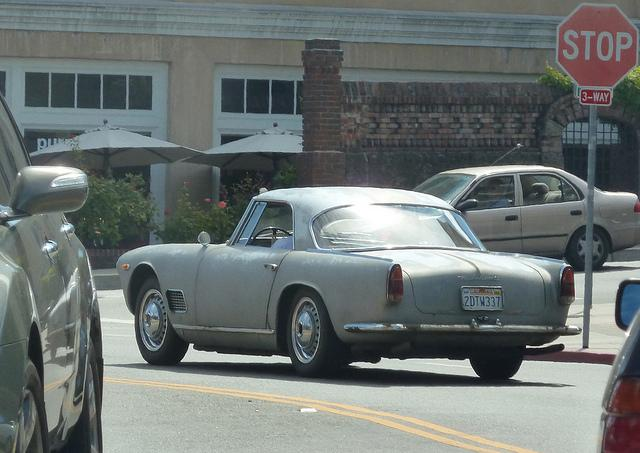How many turn options do cars entering this intersection have? Please explain your reasoning. two. The intersection is three-way type so if the car doesn't keep going straight, it can either turn right or left, which equals a total of two turn options. 